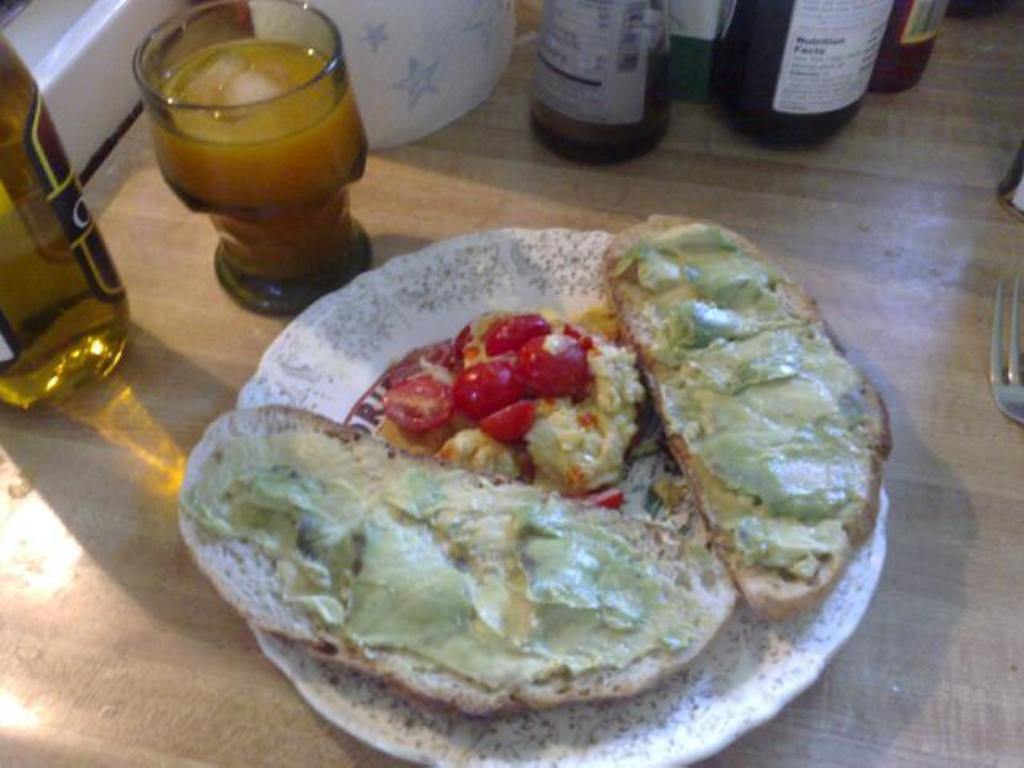What type of food is on the plate in the image? There is meat and food on the plate in the image. What is the glass used for in the image? The glass is likely used for holding a beverage. What is the bottle in the image? The bottle is likely used for holding a liquid, such as a sauce or condiment. What utensil is present in the image? There is a fork in the image. Where are all the items located in the image? All the items are on a table. How many cherries are on top of the pizzas in the image? There are no pizzas or cherries present in the image. 